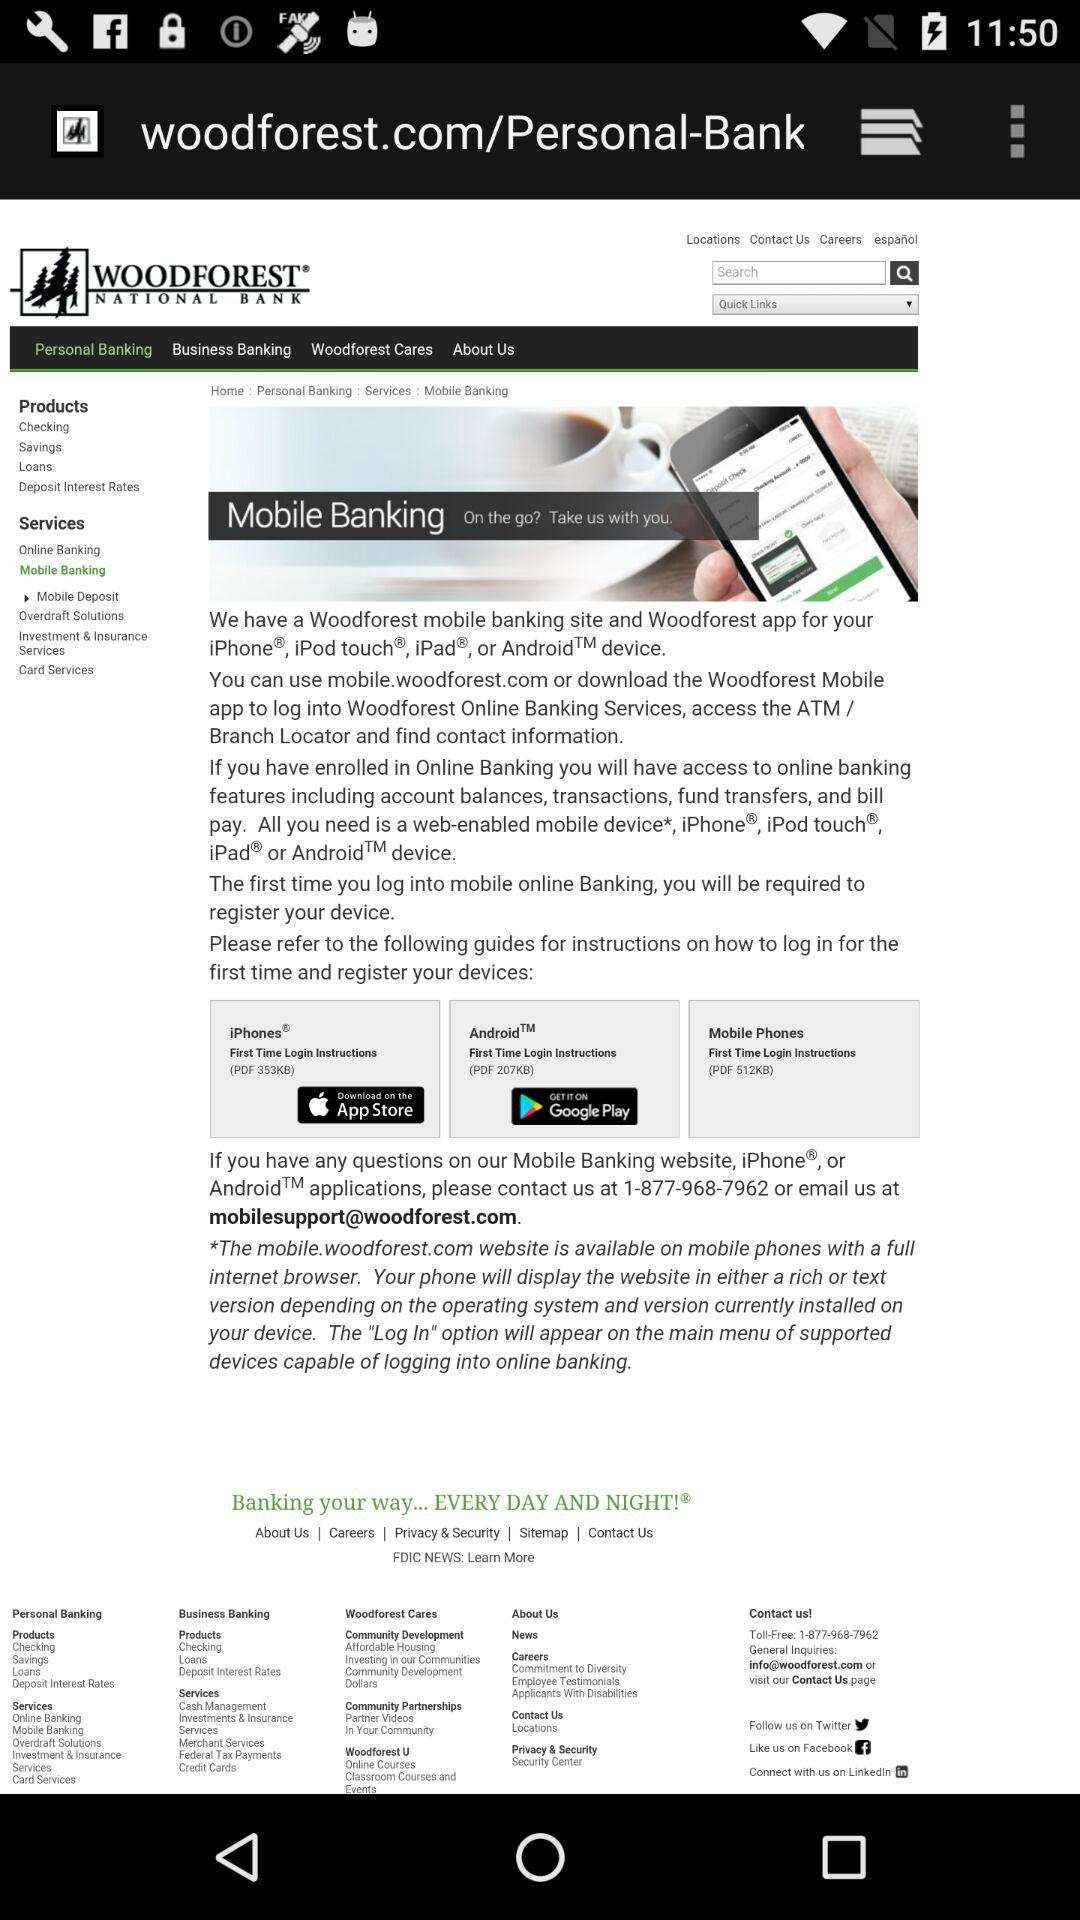What is the name of the application? The application name is "WOODFOREST". 